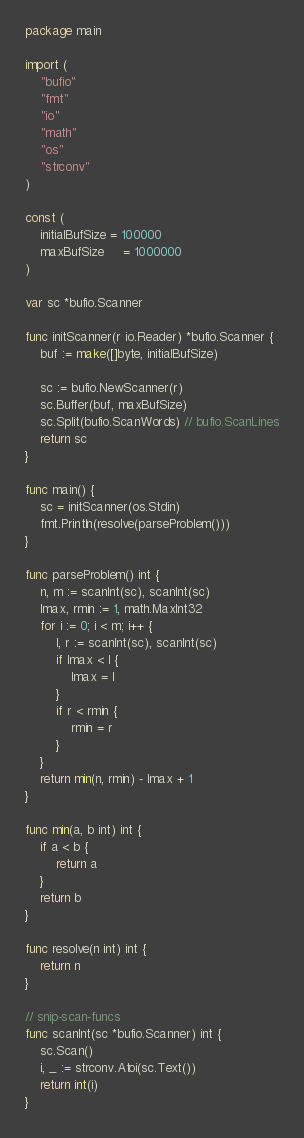<code> <loc_0><loc_0><loc_500><loc_500><_Go_>package main

import (
	"bufio"
	"fmt"
	"io"
	"math"
	"os"
	"strconv"
)

const (
	initialBufSize = 100000
	maxBufSize     = 1000000
)

var sc *bufio.Scanner

func initScanner(r io.Reader) *bufio.Scanner {
	buf := make([]byte, initialBufSize)

	sc := bufio.NewScanner(r)
	sc.Buffer(buf, maxBufSize)
	sc.Split(bufio.ScanWords) // bufio.ScanLines
	return sc
}

func main() {
	sc = initScanner(os.Stdin)
	fmt.Println(resolve(parseProblem()))
}

func parseProblem() int {
	n, m := scanInt(sc), scanInt(sc)
	lmax, rmin := 1, math.MaxInt32
	for i := 0; i < m; i++ {
		l, r := scanInt(sc), scanInt(sc)
		if lmax < l {
			lmax = l
		}
		if r < rmin {
			rmin = r
		}
	}
	return min(n, rmin) - lmax + 1
}

func min(a, b int) int {
	if a < b {
		return a
	}
	return b
}

func resolve(n int) int {
	return n
}

// snip-scan-funcs
func scanInt(sc *bufio.Scanner) int {
	sc.Scan()
	i, _ := strconv.Atoi(sc.Text())
	return int(i)
}
</code> 